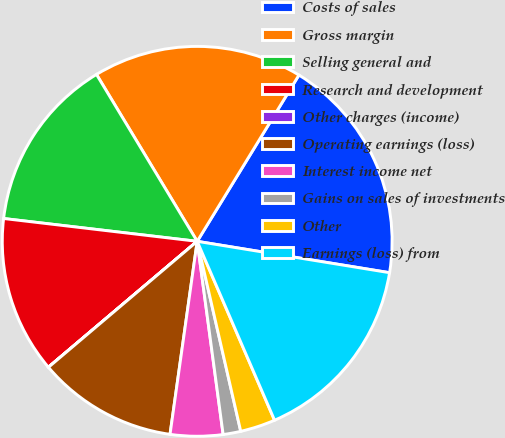Convert chart to OTSL. <chart><loc_0><loc_0><loc_500><loc_500><pie_chart><fcel>Costs of sales<fcel>Gross margin<fcel>Selling general and<fcel>Research and development<fcel>Other charges (income)<fcel>Operating earnings (loss)<fcel>Interest income net<fcel>Gains on sales of investments<fcel>Other<fcel>Earnings (loss) from<nl><fcel>18.83%<fcel>17.38%<fcel>14.49%<fcel>13.04%<fcel>0.01%<fcel>11.59%<fcel>4.35%<fcel>1.46%<fcel>2.91%<fcel>15.93%<nl></chart> 